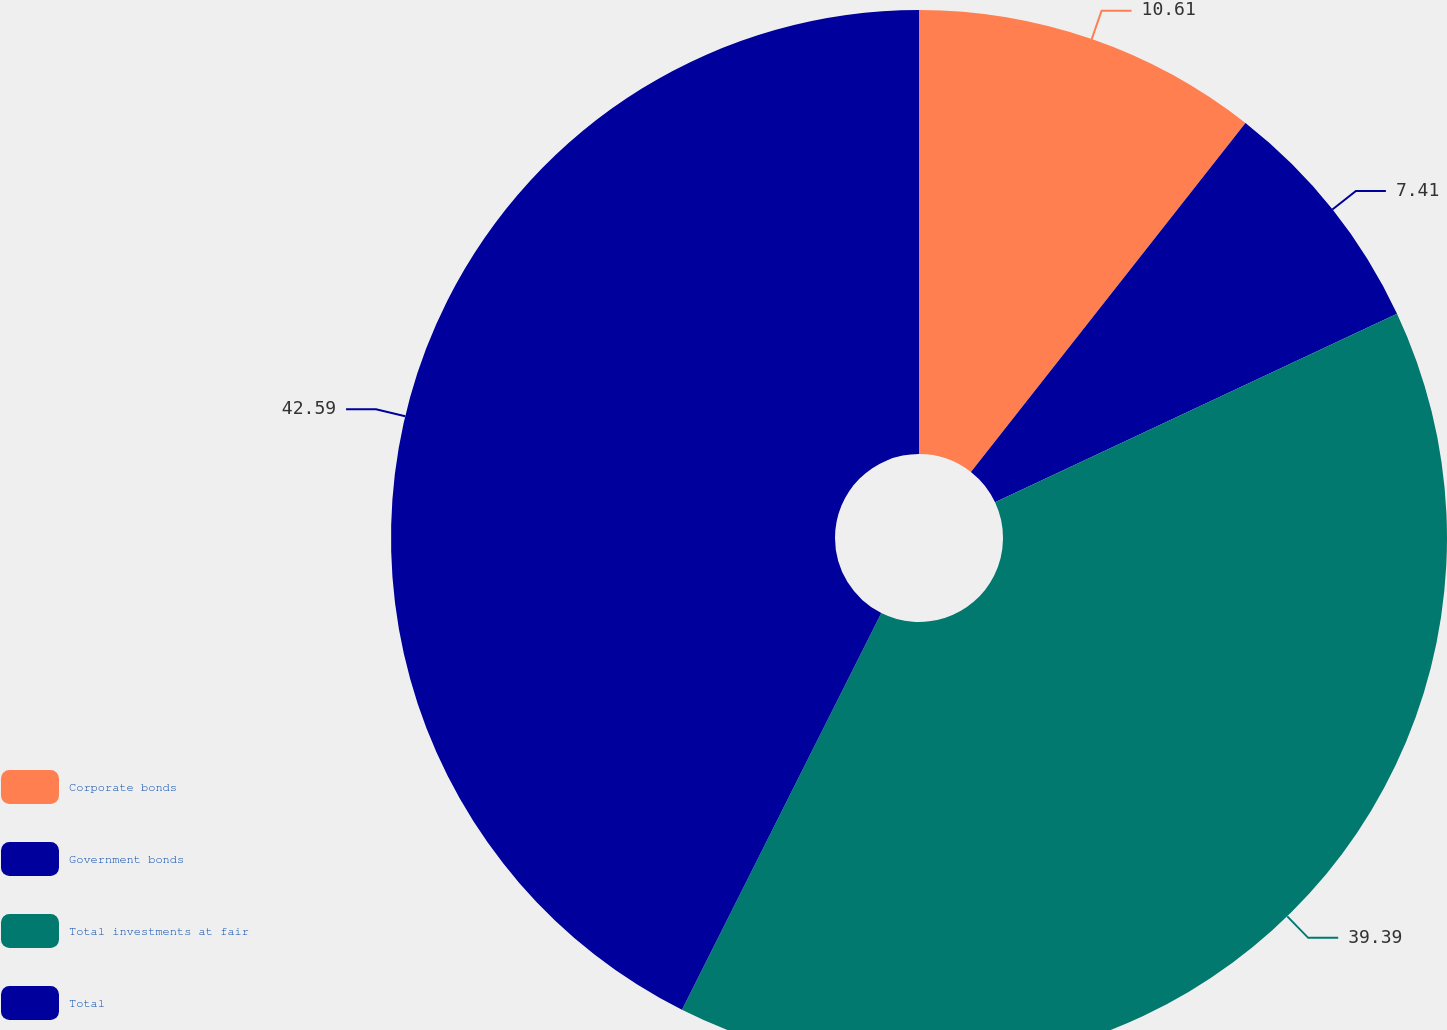Convert chart to OTSL. <chart><loc_0><loc_0><loc_500><loc_500><pie_chart><fcel>Corporate bonds<fcel>Government bonds<fcel>Total investments at fair<fcel>Total<nl><fcel>10.61%<fcel>7.41%<fcel>39.39%<fcel>42.59%<nl></chart> 